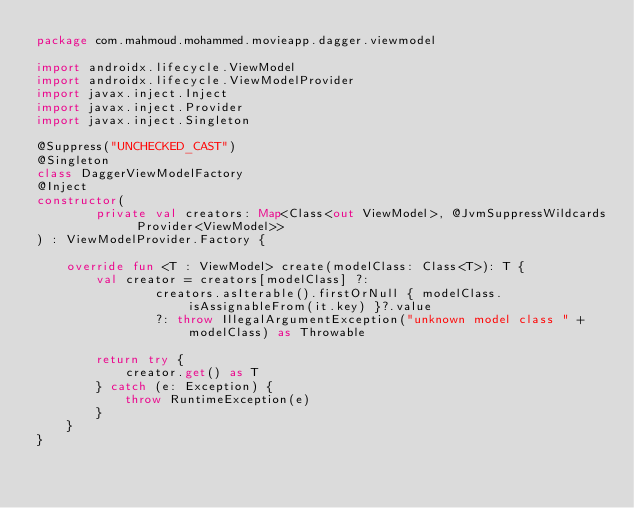Convert code to text. <code><loc_0><loc_0><loc_500><loc_500><_Kotlin_>package com.mahmoud.mohammed.movieapp.dagger.viewmodel

import androidx.lifecycle.ViewModel
import androidx.lifecycle.ViewModelProvider
import javax.inject.Inject
import javax.inject.Provider
import javax.inject.Singleton

@Suppress("UNCHECKED_CAST")
@Singleton
class DaggerViewModelFactory
@Inject
constructor(
        private val creators: Map<Class<out ViewModel>, @JvmSuppressWildcards Provider<ViewModel>>
) : ViewModelProvider.Factory {

    override fun <T : ViewModel> create(modelClass: Class<T>): T {
        val creator = creators[modelClass] ?:
                creators.asIterable().firstOrNull { modelClass.isAssignableFrom(it.key) }?.value
                ?: throw IllegalArgumentException("unknown model class " + modelClass) as Throwable

        return try {
            creator.get() as T
        } catch (e: Exception) {
            throw RuntimeException(e)
        }
    }
}</code> 